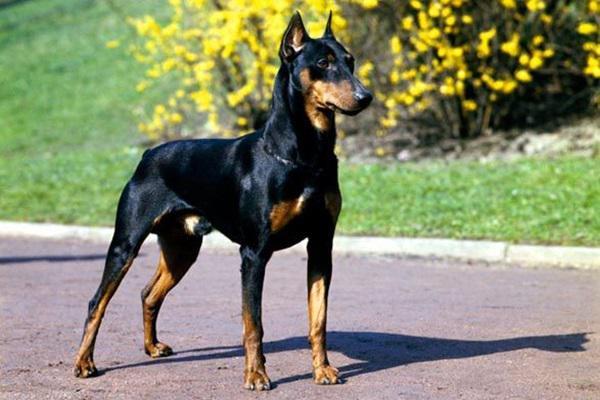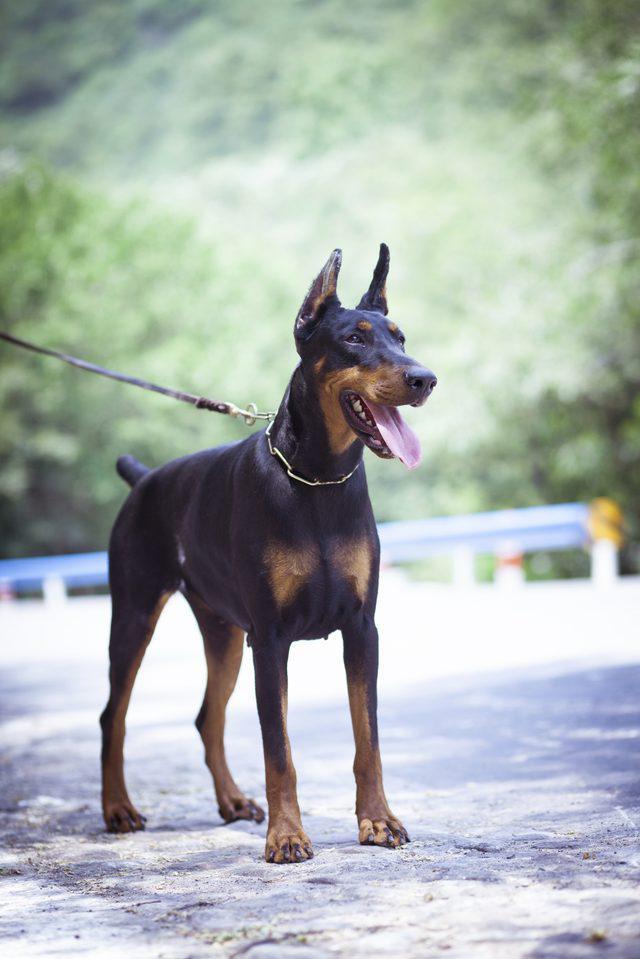The first image is the image on the left, the second image is the image on the right. For the images shown, is this caption "There are only two dogs." true? Answer yes or no. Yes. The first image is the image on the left, the second image is the image on the right. Evaluate the accuracy of this statement regarding the images: "There are exactly two dogs.". Is it true? Answer yes or no. Yes. 